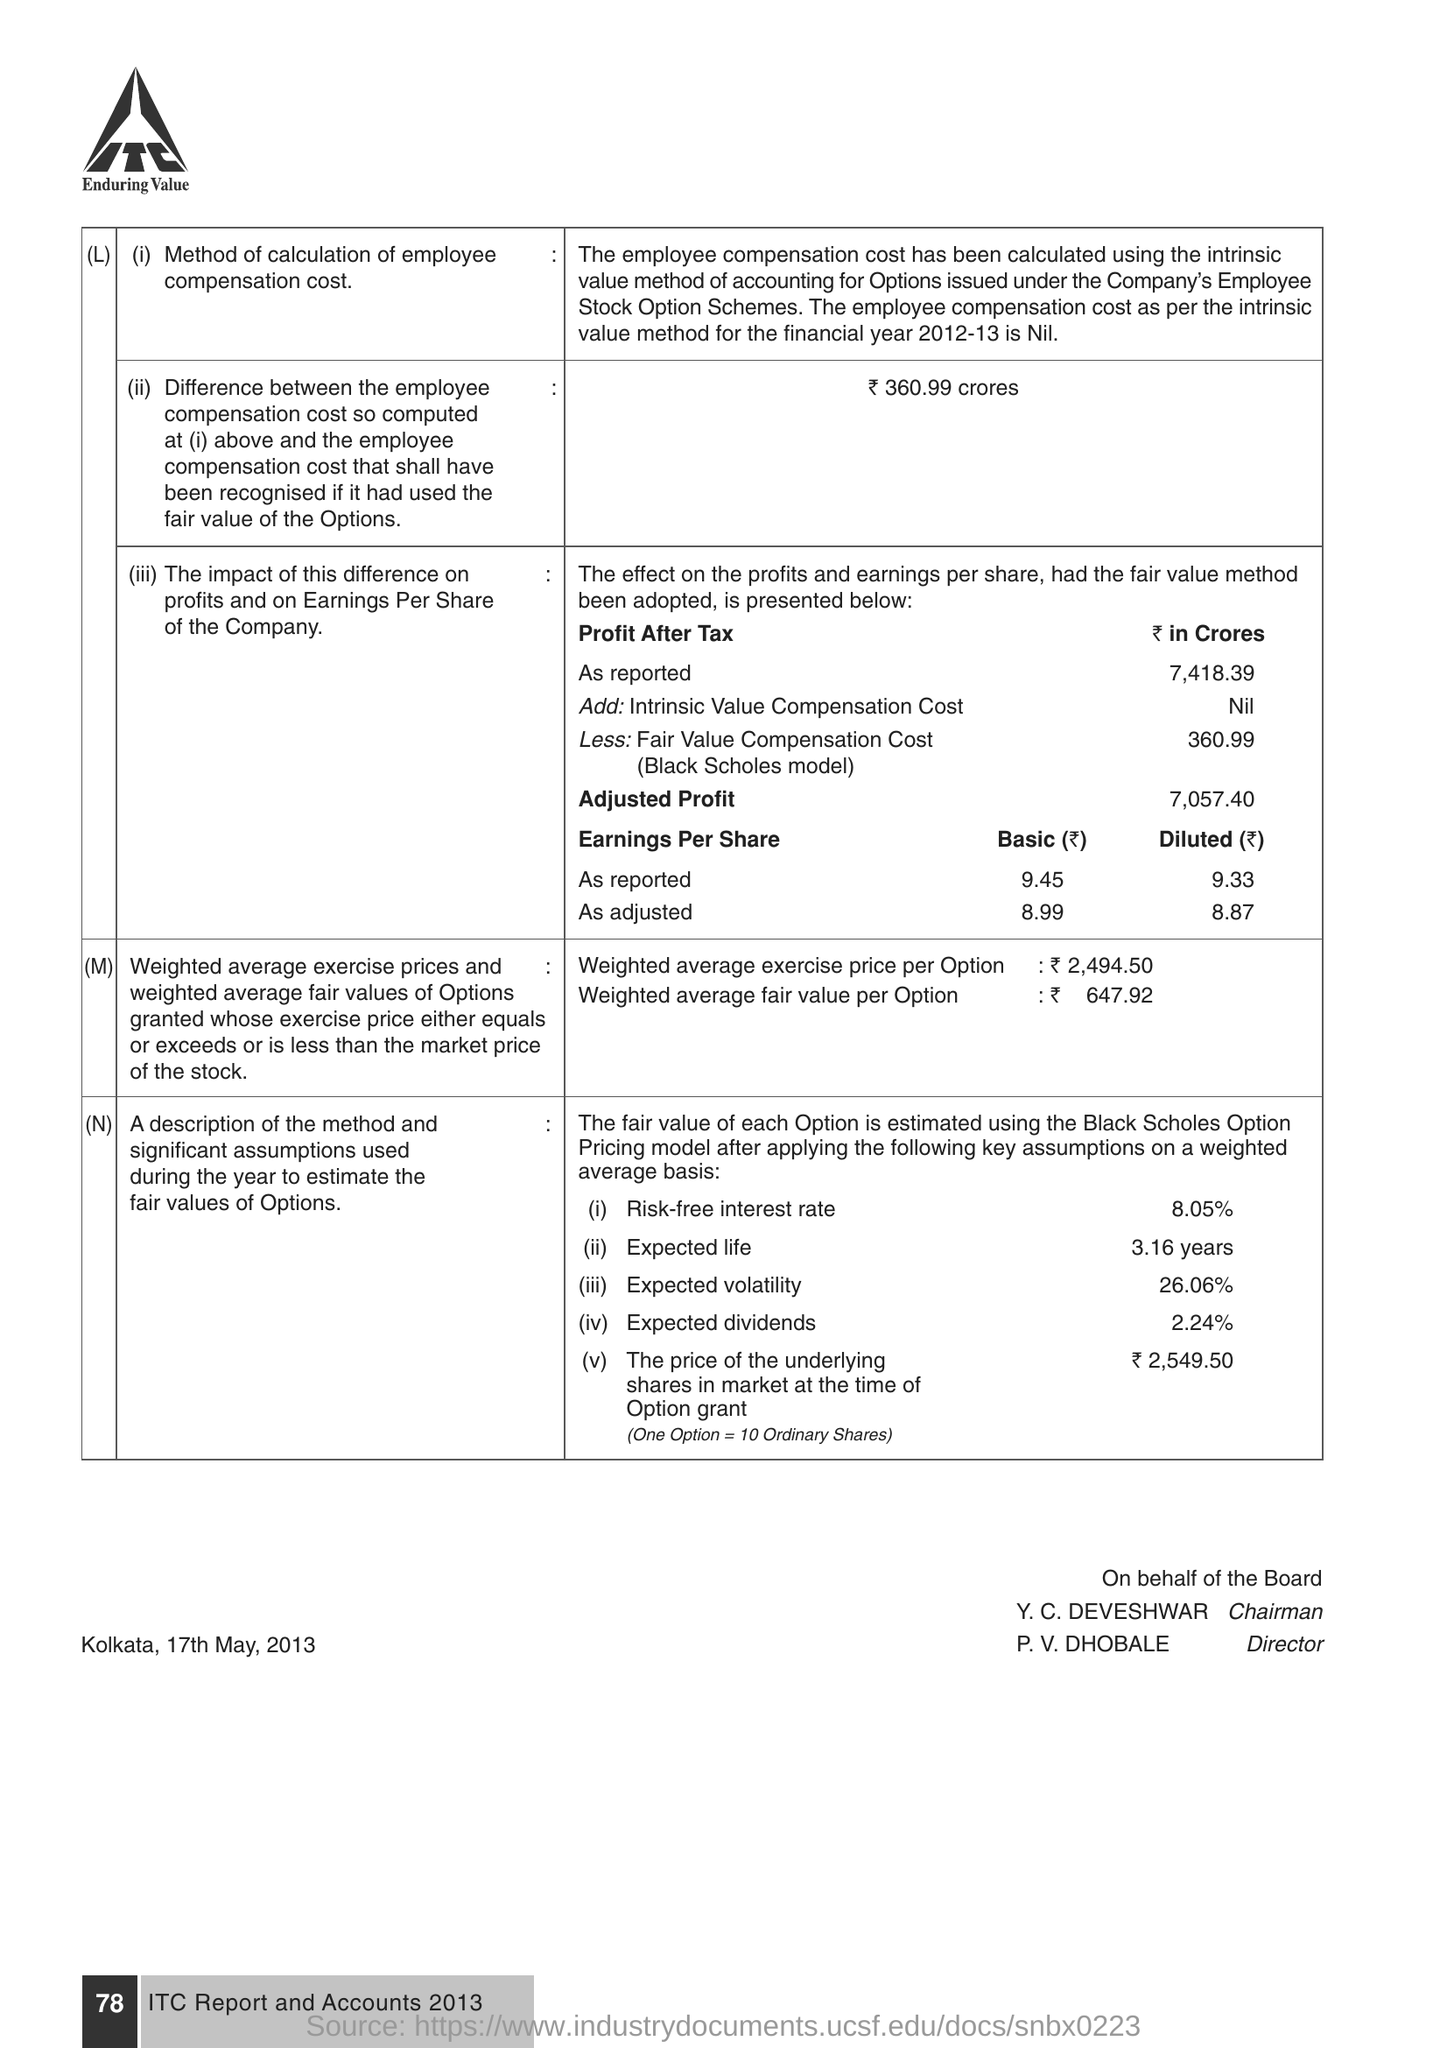How much Risk -Free interest rate ?
Provide a succinct answer. 8.05%. Who is the Chairman ?
Your response must be concise. Y. C. DEVESHWAR. Who is the Director ?
Provide a succinct answer. P. V. DHOBALE. 